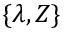<formula> <loc_0><loc_0><loc_500><loc_500>\{ \lambda , Z \}</formula> 